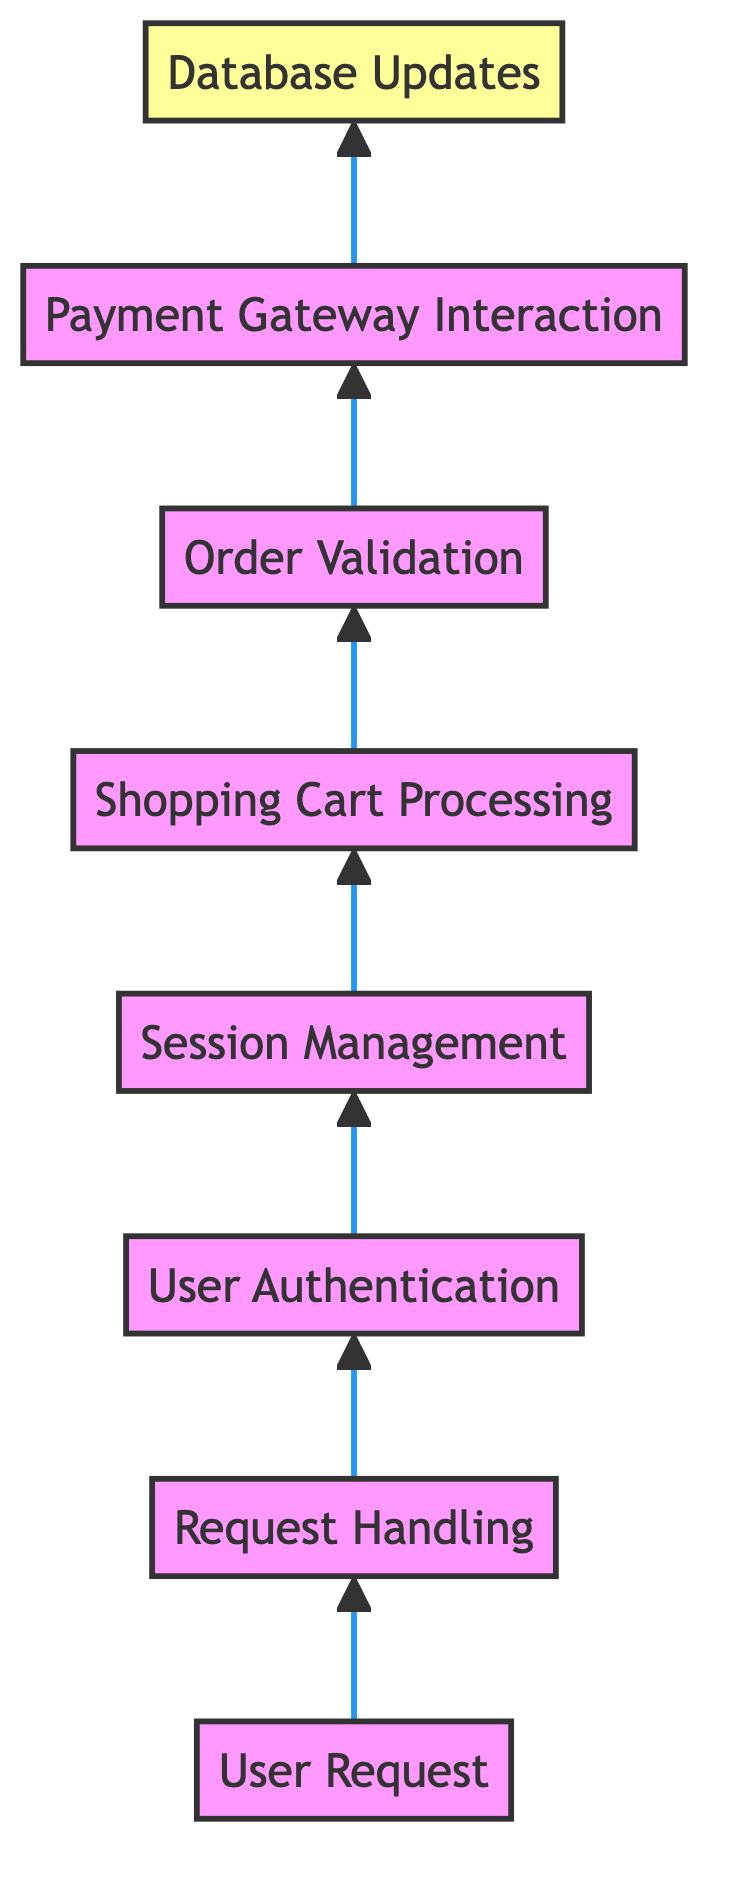What is the first step in the flow chart? The first step in the flow chart is the "User Request", which initiates the process. It is at the bottom of the diagram, indicating it is the starting point for the transaction process.
Answer: User Request How many nodes are present in the flow chart? There are a total of eight nodes in the flow chart, including "User Request" and "Database Updates", with each node representing a key step in the e-commerce transaction process.
Answer: Eight What action follows "Session Management"? The action that follows "Session Management" is "Shopping Cart Processing". This means that once user sessions are managed, the next step is to process the items in the shopping cart.
Answer: Shopping Cart Processing Which step comes before "Order Validation"? The step that comes before "Order Validation" is "Shopping Cart Processing". This indicates that the shopping cart needs to be processed, including calculations, before validating the order.
Answer: Shopping Cart Processing What is the final action in the flow chart? The final action in the flow chart is "Database Updates". This means after all processes, the last step involves updating the database with inventory levels and customer purchase records.
Answer: Database Updates How many interactions occur before "Payment Gateway Interaction"? Three interactions occur before "Payment Gateway Interaction": "User Authentication", "Session Management", and "Shopping Cart Processing". This indicates that these steps must be completed prior to processing the payment.
Answer: Three What type of requests does "Request Handling" process? "Request Handling" processes HTTP requests initiated by the user from the interface, which could come in the form of web forms or API calls.
Answer: HTTP requests What is the primary role of "User Authentication"? The primary role of "User Authentication" is to verify user credentials, ensuring the user is who they claim to be before proceeding with the transaction.
Answer: Verify user credentials 